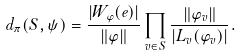<formula> <loc_0><loc_0><loc_500><loc_500>d _ { \pi } ( S , \psi ) = \frac { | W _ { \varphi } ( e ) | } { \| \varphi \| } \prod _ { v \in S } \frac { \| \varphi _ { v } \| } { | L _ { v } ( \varphi _ { v } ) | } .</formula> 